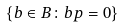<formula> <loc_0><loc_0><loc_500><loc_500>\{ b \in B \colon b p = 0 \}</formula> 